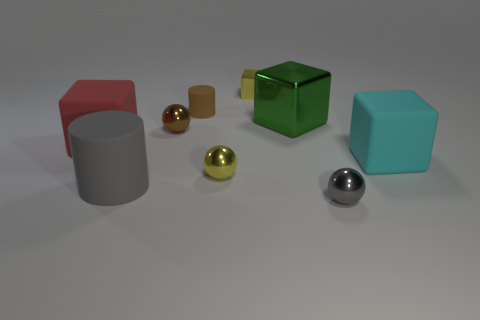Subtract all big metal cubes. How many cubes are left? 3 Add 1 small brown shiny things. How many objects exist? 10 Subtract all brown cylinders. How many cylinders are left? 1 Subtract 2 spheres. How many spheres are left? 1 Subtract all spheres. How many objects are left? 6 Add 2 tiny brown things. How many tiny brown things are left? 4 Add 5 yellow matte things. How many yellow matte things exist? 5 Subtract 0 purple balls. How many objects are left? 9 Subtract all blue cylinders. Subtract all cyan spheres. How many cylinders are left? 2 Subtract all gray balls. How many gray cylinders are left? 1 